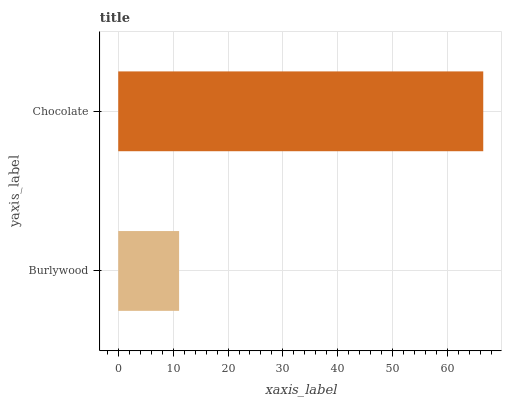Is Burlywood the minimum?
Answer yes or no. Yes. Is Chocolate the maximum?
Answer yes or no. Yes. Is Chocolate the minimum?
Answer yes or no. No. Is Chocolate greater than Burlywood?
Answer yes or no. Yes. Is Burlywood less than Chocolate?
Answer yes or no. Yes. Is Burlywood greater than Chocolate?
Answer yes or no. No. Is Chocolate less than Burlywood?
Answer yes or no. No. Is Chocolate the high median?
Answer yes or no. Yes. Is Burlywood the low median?
Answer yes or no. Yes. Is Burlywood the high median?
Answer yes or no. No. Is Chocolate the low median?
Answer yes or no. No. 